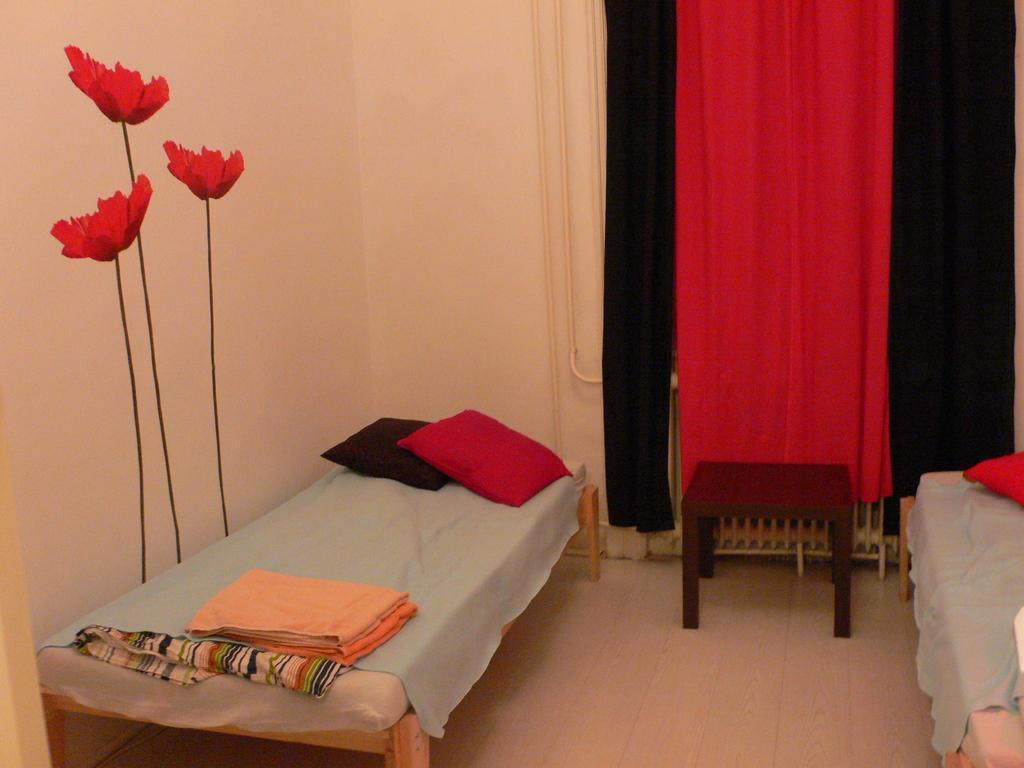In one or two sentences, can you explain what this image depicts? Here we can see a bed with cushions on it and here there is a blanket and on the left side there is a wall with flower painting on it and in the center there is a table and curtains of various colors 